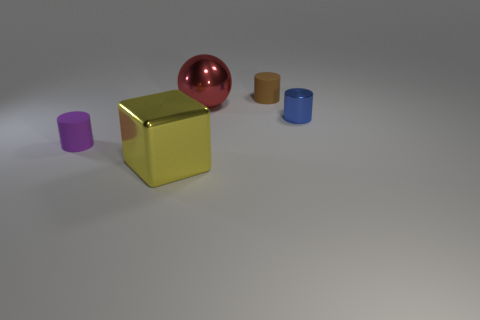Subtract all purple cylinders. How many cylinders are left? 2 Add 4 red rubber cubes. How many objects exist? 9 Subtract all cylinders. How many objects are left? 2 Subtract all blue spheres. Subtract all purple blocks. How many spheres are left? 1 Subtract all big spheres. Subtract all tiny blue metal things. How many objects are left? 3 Add 1 blue objects. How many blue objects are left? 2 Add 1 metal blocks. How many metal blocks exist? 2 Subtract 0 green cubes. How many objects are left? 5 